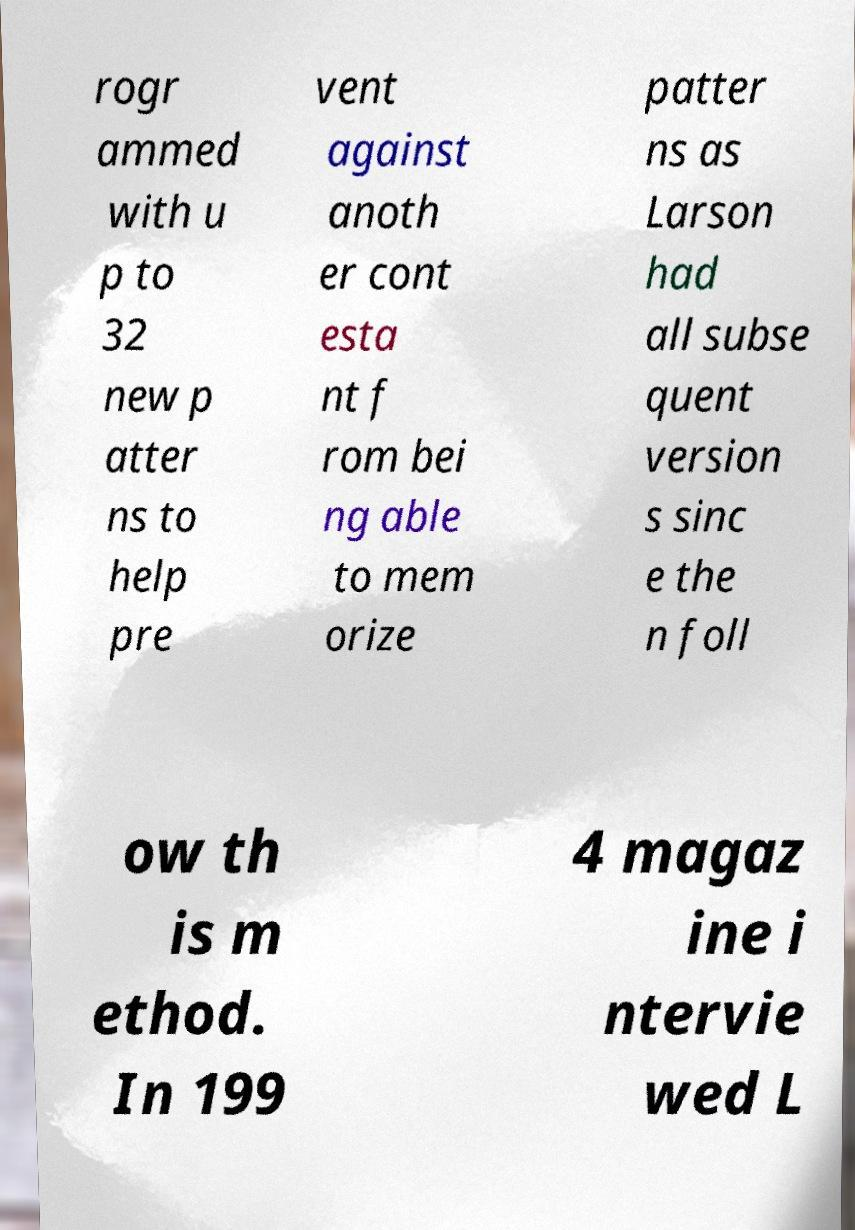What messages or text are displayed in this image? I need them in a readable, typed format. rogr ammed with u p to 32 new p atter ns to help pre vent against anoth er cont esta nt f rom bei ng able to mem orize patter ns as Larson had all subse quent version s sinc e the n foll ow th is m ethod. In 199 4 magaz ine i ntervie wed L 